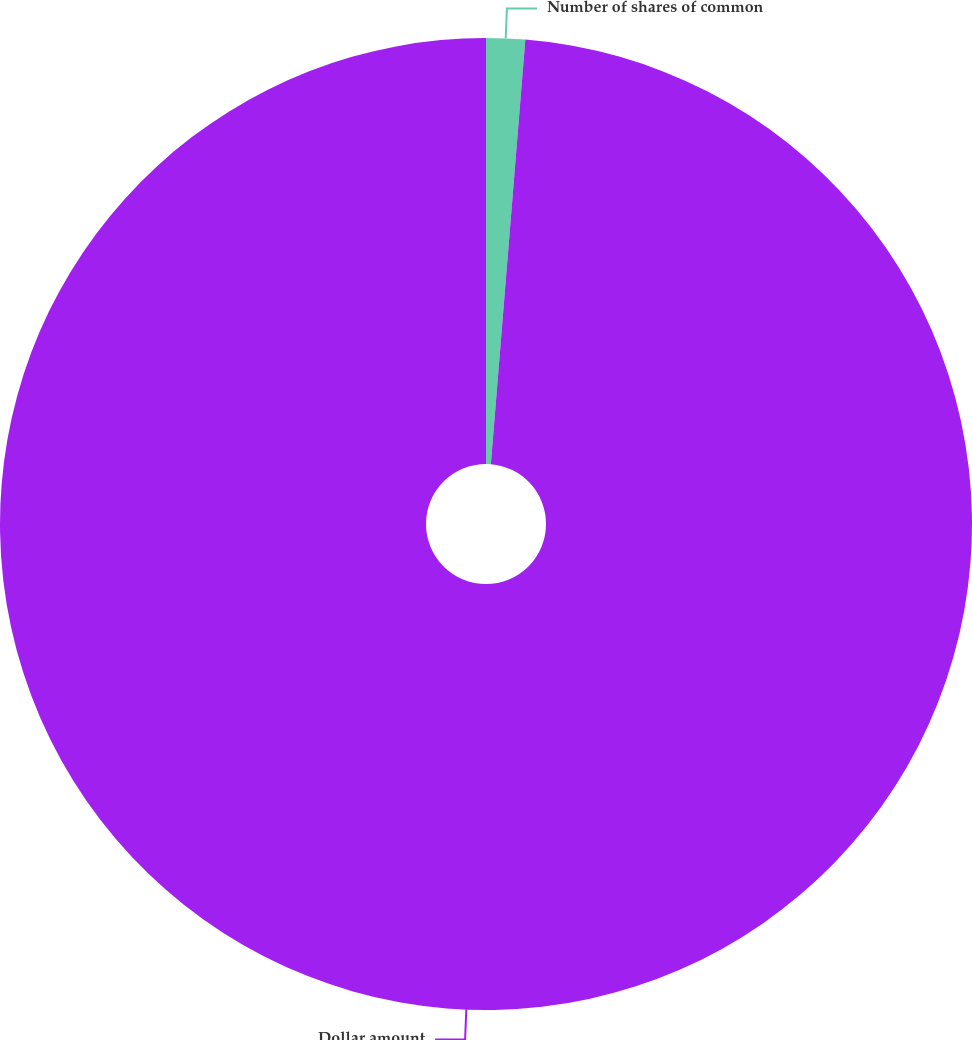Convert chart. <chart><loc_0><loc_0><loc_500><loc_500><pie_chart><fcel>Number of shares of common<fcel>Dollar amount<nl><fcel>1.29%<fcel>98.71%<nl></chart> 